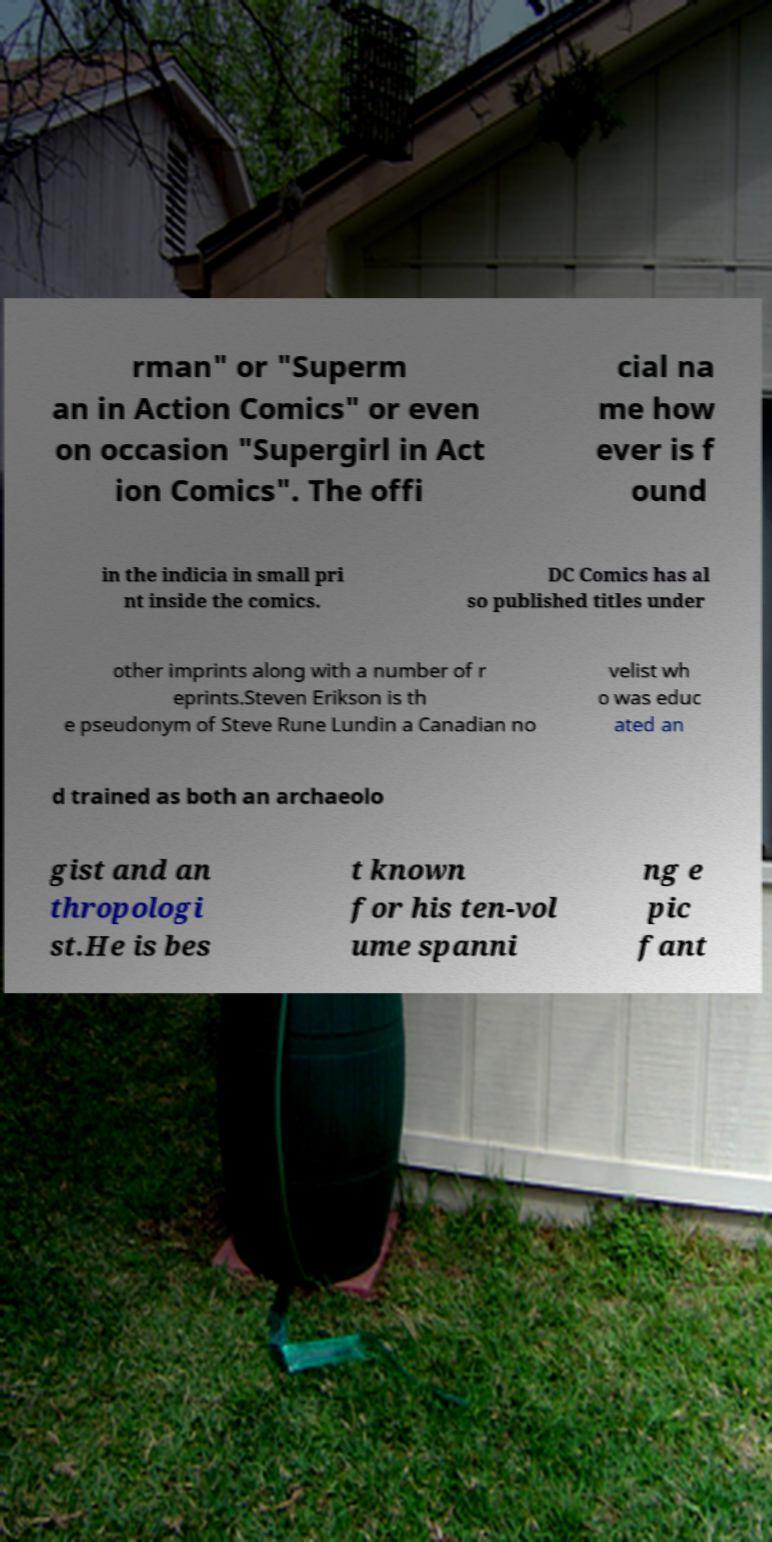Can you read and provide the text displayed in the image?This photo seems to have some interesting text. Can you extract and type it out for me? rman" or "Superm an in Action Comics" or even on occasion "Supergirl in Act ion Comics". The offi cial na me how ever is f ound in the indicia in small pri nt inside the comics. DC Comics has al so published titles under other imprints along with a number of r eprints.Steven Erikson is th e pseudonym of Steve Rune Lundin a Canadian no velist wh o was educ ated an d trained as both an archaeolo gist and an thropologi st.He is bes t known for his ten-vol ume spanni ng e pic fant 